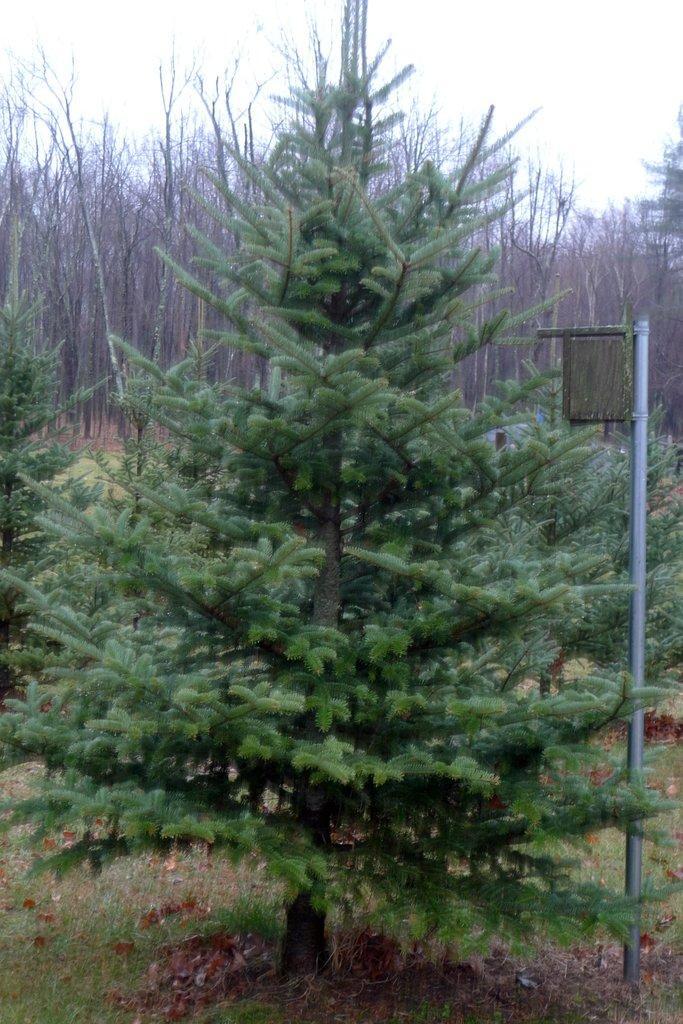Can you describe this image briefly? In this image we can see a group of trees, grass, a pole and the sky. 